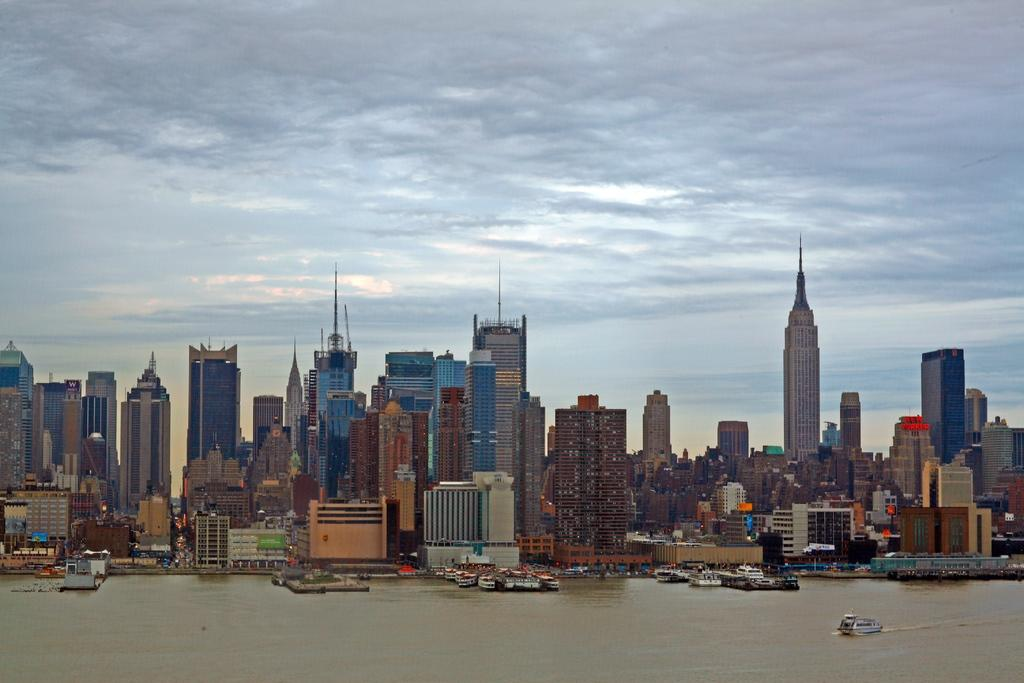What is on the water in the image? There are boats on the water in the image. What else can be seen in the image besides the boats? There are buildings visible in the image. What is visible in the background of the image? The sky is visible in the background of the image. What can be observed in the sky? Clouds are present in the sky. What theory is the stranger discussing with the boats in the image? There is no stranger present in the image, and therefore no discussion or theory can be observed. 